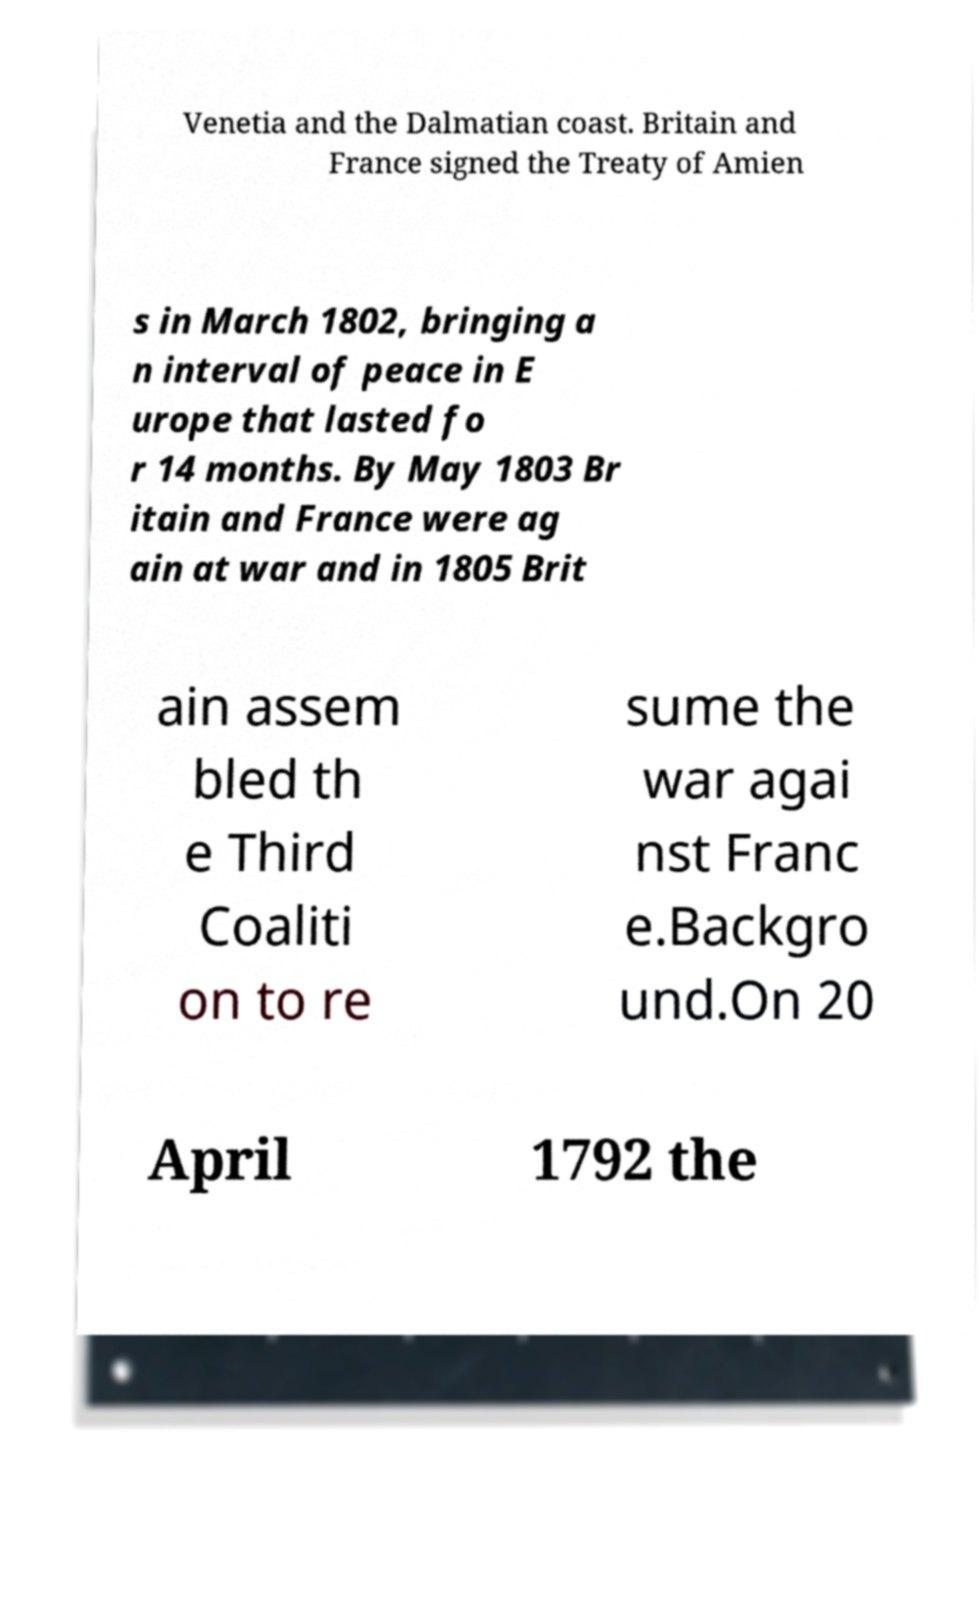Please read and relay the text visible in this image. What does it say? Venetia and the Dalmatian coast. Britain and France signed the Treaty of Amien s in March 1802, bringing a n interval of peace in E urope that lasted fo r 14 months. By May 1803 Br itain and France were ag ain at war and in 1805 Brit ain assem bled th e Third Coaliti on to re sume the war agai nst Franc e.Backgro und.On 20 April 1792 the 